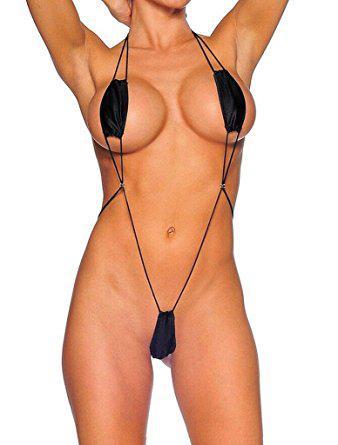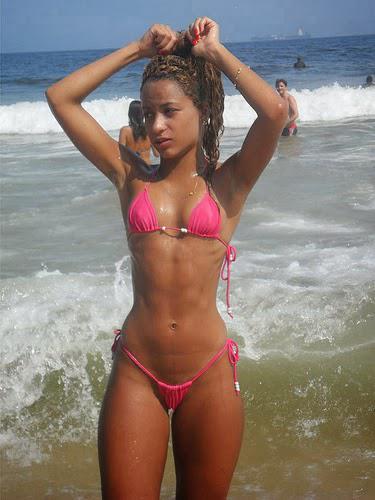The first image is the image on the left, the second image is the image on the right. Evaluate the accuracy of this statement regarding the images: "There is exactly one woman in a swimsuit in each image.". Is it true? Answer yes or no. Yes. The first image is the image on the left, the second image is the image on the right. For the images shown, is this caption "In the left image, the bikini is black." true? Answer yes or no. Yes. 